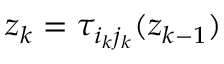<formula> <loc_0><loc_0><loc_500><loc_500>z _ { k } = \tau _ { i _ { k } j _ { k } } ( z _ { k - 1 } )</formula> 